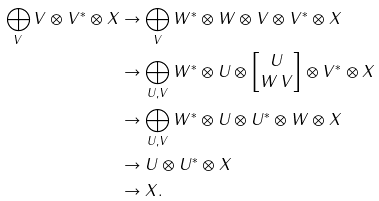<formula> <loc_0><loc_0><loc_500><loc_500>\bigoplus _ { V } V \otimes V ^ { * } \otimes X & \to \bigoplus _ { V } W ^ { * } \otimes W \otimes V \otimes V ^ { * } \otimes X \\ & \to \bigoplus _ { U , V } W ^ { * } \otimes U \otimes \begin{bmatrix} U \\ W \, V \end{bmatrix} \otimes V ^ { * } \otimes X \\ & \to \bigoplus _ { U , V } W ^ { * } \otimes U \otimes U ^ { * } \otimes W \otimes X \\ & \to U \otimes U ^ { * } \otimes X \\ & \to X .</formula> 